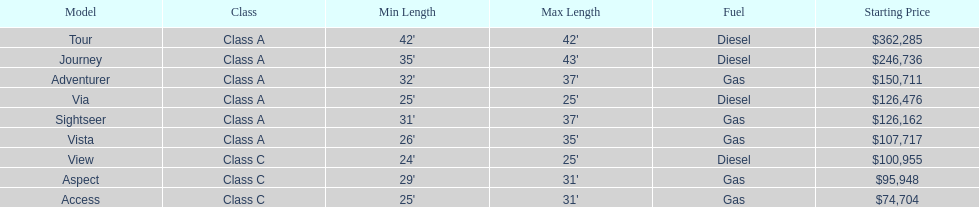Which model had the highest starting price Tour. 